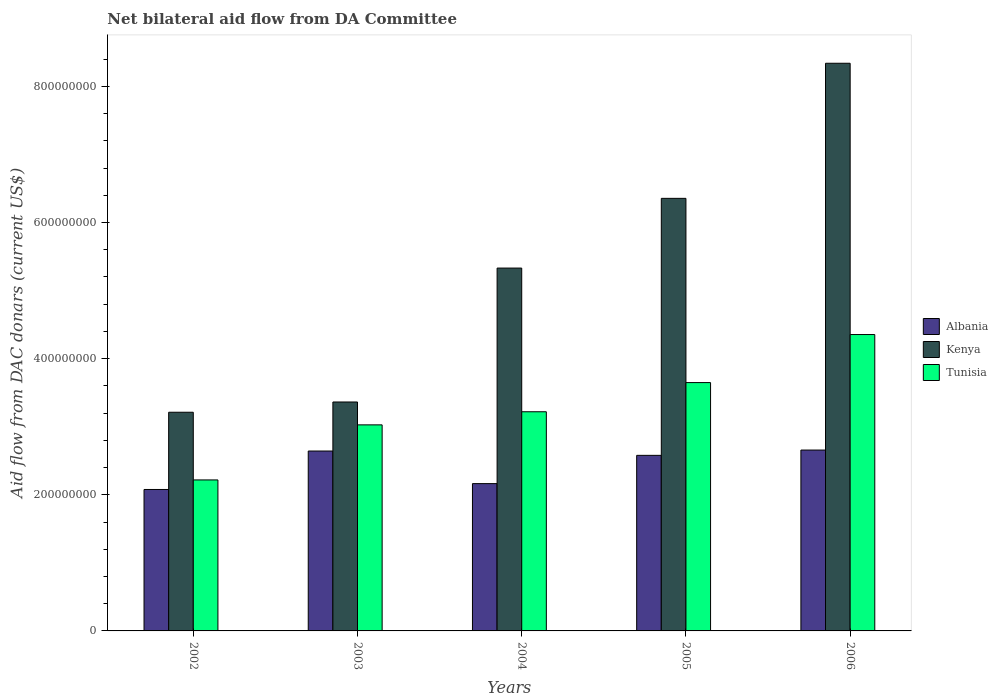How many groups of bars are there?
Give a very brief answer. 5. What is the aid flow in in Tunisia in 2005?
Provide a short and direct response. 3.65e+08. Across all years, what is the maximum aid flow in in Albania?
Keep it short and to the point. 2.66e+08. Across all years, what is the minimum aid flow in in Albania?
Make the answer very short. 2.08e+08. In which year was the aid flow in in Albania maximum?
Keep it short and to the point. 2006. What is the total aid flow in in Kenya in the graph?
Your answer should be very brief. 2.66e+09. What is the difference between the aid flow in in Albania in 2003 and that in 2004?
Offer a very short reply. 4.79e+07. What is the difference between the aid flow in in Tunisia in 2005 and the aid flow in in Kenya in 2006?
Your response must be concise. -4.69e+08. What is the average aid flow in in Albania per year?
Your answer should be very brief. 2.42e+08. In the year 2006, what is the difference between the aid flow in in Kenya and aid flow in in Tunisia?
Make the answer very short. 3.99e+08. In how many years, is the aid flow in in Kenya greater than 240000000 US$?
Your answer should be compact. 5. What is the ratio of the aid flow in in Albania in 2002 to that in 2006?
Your answer should be compact. 0.78. Is the difference between the aid flow in in Kenya in 2004 and 2006 greater than the difference between the aid flow in in Tunisia in 2004 and 2006?
Provide a short and direct response. No. What is the difference between the highest and the second highest aid flow in in Tunisia?
Keep it short and to the point. 7.06e+07. What is the difference between the highest and the lowest aid flow in in Kenya?
Make the answer very short. 5.13e+08. What does the 2nd bar from the left in 2006 represents?
Ensure brevity in your answer.  Kenya. What does the 3rd bar from the right in 2005 represents?
Your response must be concise. Albania. Is it the case that in every year, the sum of the aid flow in in Tunisia and aid flow in in Kenya is greater than the aid flow in in Albania?
Make the answer very short. Yes. How many bars are there?
Offer a terse response. 15. Are all the bars in the graph horizontal?
Give a very brief answer. No. How many years are there in the graph?
Keep it short and to the point. 5. What is the difference between two consecutive major ticks on the Y-axis?
Keep it short and to the point. 2.00e+08. Where does the legend appear in the graph?
Make the answer very short. Center right. How many legend labels are there?
Offer a very short reply. 3. How are the legend labels stacked?
Ensure brevity in your answer.  Vertical. What is the title of the graph?
Your response must be concise. Net bilateral aid flow from DA Committee. What is the label or title of the Y-axis?
Give a very brief answer. Aid flow from DAC donars (current US$). What is the Aid flow from DAC donars (current US$) in Albania in 2002?
Your response must be concise. 2.08e+08. What is the Aid flow from DAC donars (current US$) of Kenya in 2002?
Provide a succinct answer. 3.21e+08. What is the Aid flow from DAC donars (current US$) in Tunisia in 2002?
Your answer should be very brief. 2.22e+08. What is the Aid flow from DAC donars (current US$) in Albania in 2003?
Your response must be concise. 2.64e+08. What is the Aid flow from DAC donars (current US$) of Kenya in 2003?
Ensure brevity in your answer.  3.36e+08. What is the Aid flow from DAC donars (current US$) in Tunisia in 2003?
Your response must be concise. 3.03e+08. What is the Aid flow from DAC donars (current US$) of Albania in 2004?
Offer a terse response. 2.16e+08. What is the Aid flow from DAC donars (current US$) in Kenya in 2004?
Ensure brevity in your answer.  5.33e+08. What is the Aid flow from DAC donars (current US$) in Tunisia in 2004?
Provide a succinct answer. 3.22e+08. What is the Aid flow from DAC donars (current US$) in Albania in 2005?
Your answer should be compact. 2.58e+08. What is the Aid flow from DAC donars (current US$) in Kenya in 2005?
Make the answer very short. 6.35e+08. What is the Aid flow from DAC donars (current US$) of Tunisia in 2005?
Provide a succinct answer. 3.65e+08. What is the Aid flow from DAC donars (current US$) in Albania in 2006?
Give a very brief answer. 2.66e+08. What is the Aid flow from DAC donars (current US$) of Kenya in 2006?
Your answer should be compact. 8.34e+08. What is the Aid flow from DAC donars (current US$) of Tunisia in 2006?
Provide a succinct answer. 4.35e+08. Across all years, what is the maximum Aid flow from DAC donars (current US$) in Albania?
Offer a very short reply. 2.66e+08. Across all years, what is the maximum Aid flow from DAC donars (current US$) of Kenya?
Your response must be concise. 8.34e+08. Across all years, what is the maximum Aid flow from DAC donars (current US$) in Tunisia?
Offer a very short reply. 4.35e+08. Across all years, what is the minimum Aid flow from DAC donars (current US$) in Albania?
Your answer should be compact. 2.08e+08. Across all years, what is the minimum Aid flow from DAC donars (current US$) of Kenya?
Your response must be concise. 3.21e+08. Across all years, what is the minimum Aid flow from DAC donars (current US$) of Tunisia?
Give a very brief answer. 2.22e+08. What is the total Aid flow from DAC donars (current US$) of Albania in the graph?
Offer a terse response. 1.21e+09. What is the total Aid flow from DAC donars (current US$) of Kenya in the graph?
Offer a very short reply. 2.66e+09. What is the total Aid flow from DAC donars (current US$) in Tunisia in the graph?
Give a very brief answer. 1.65e+09. What is the difference between the Aid flow from DAC donars (current US$) of Albania in 2002 and that in 2003?
Offer a terse response. -5.65e+07. What is the difference between the Aid flow from DAC donars (current US$) in Kenya in 2002 and that in 2003?
Give a very brief answer. -1.51e+07. What is the difference between the Aid flow from DAC donars (current US$) in Tunisia in 2002 and that in 2003?
Keep it short and to the point. -8.09e+07. What is the difference between the Aid flow from DAC donars (current US$) in Albania in 2002 and that in 2004?
Make the answer very short. -8.60e+06. What is the difference between the Aid flow from DAC donars (current US$) in Kenya in 2002 and that in 2004?
Offer a terse response. -2.12e+08. What is the difference between the Aid flow from DAC donars (current US$) of Tunisia in 2002 and that in 2004?
Your answer should be compact. -1.00e+08. What is the difference between the Aid flow from DAC donars (current US$) of Albania in 2002 and that in 2005?
Keep it short and to the point. -5.01e+07. What is the difference between the Aid flow from DAC donars (current US$) in Kenya in 2002 and that in 2005?
Make the answer very short. -3.14e+08. What is the difference between the Aid flow from DAC donars (current US$) of Tunisia in 2002 and that in 2005?
Your answer should be very brief. -1.43e+08. What is the difference between the Aid flow from DAC donars (current US$) of Albania in 2002 and that in 2006?
Your response must be concise. -5.79e+07. What is the difference between the Aid flow from DAC donars (current US$) in Kenya in 2002 and that in 2006?
Your response must be concise. -5.13e+08. What is the difference between the Aid flow from DAC donars (current US$) in Tunisia in 2002 and that in 2006?
Give a very brief answer. -2.14e+08. What is the difference between the Aid flow from DAC donars (current US$) in Albania in 2003 and that in 2004?
Give a very brief answer. 4.79e+07. What is the difference between the Aid flow from DAC donars (current US$) of Kenya in 2003 and that in 2004?
Offer a very short reply. -1.97e+08. What is the difference between the Aid flow from DAC donars (current US$) in Tunisia in 2003 and that in 2004?
Your answer should be very brief. -1.92e+07. What is the difference between the Aid flow from DAC donars (current US$) of Albania in 2003 and that in 2005?
Ensure brevity in your answer.  6.36e+06. What is the difference between the Aid flow from DAC donars (current US$) in Kenya in 2003 and that in 2005?
Your answer should be compact. -2.99e+08. What is the difference between the Aid flow from DAC donars (current US$) in Tunisia in 2003 and that in 2005?
Your answer should be very brief. -6.21e+07. What is the difference between the Aid flow from DAC donars (current US$) in Albania in 2003 and that in 2006?
Your response must be concise. -1.43e+06. What is the difference between the Aid flow from DAC donars (current US$) in Kenya in 2003 and that in 2006?
Offer a very short reply. -4.98e+08. What is the difference between the Aid flow from DAC donars (current US$) of Tunisia in 2003 and that in 2006?
Ensure brevity in your answer.  -1.33e+08. What is the difference between the Aid flow from DAC donars (current US$) in Albania in 2004 and that in 2005?
Provide a short and direct response. -4.15e+07. What is the difference between the Aid flow from DAC donars (current US$) in Kenya in 2004 and that in 2005?
Your answer should be very brief. -1.02e+08. What is the difference between the Aid flow from DAC donars (current US$) in Tunisia in 2004 and that in 2005?
Ensure brevity in your answer.  -4.29e+07. What is the difference between the Aid flow from DAC donars (current US$) of Albania in 2004 and that in 2006?
Offer a very short reply. -4.93e+07. What is the difference between the Aid flow from DAC donars (current US$) in Kenya in 2004 and that in 2006?
Offer a terse response. -3.01e+08. What is the difference between the Aid flow from DAC donars (current US$) in Tunisia in 2004 and that in 2006?
Provide a succinct answer. -1.13e+08. What is the difference between the Aid flow from DAC donars (current US$) in Albania in 2005 and that in 2006?
Keep it short and to the point. -7.79e+06. What is the difference between the Aid flow from DAC donars (current US$) of Kenya in 2005 and that in 2006?
Offer a terse response. -1.98e+08. What is the difference between the Aid flow from DAC donars (current US$) of Tunisia in 2005 and that in 2006?
Give a very brief answer. -7.06e+07. What is the difference between the Aid flow from DAC donars (current US$) in Albania in 2002 and the Aid flow from DAC donars (current US$) in Kenya in 2003?
Make the answer very short. -1.29e+08. What is the difference between the Aid flow from DAC donars (current US$) of Albania in 2002 and the Aid flow from DAC donars (current US$) of Tunisia in 2003?
Provide a succinct answer. -9.49e+07. What is the difference between the Aid flow from DAC donars (current US$) in Kenya in 2002 and the Aid flow from DAC donars (current US$) in Tunisia in 2003?
Your answer should be very brief. 1.85e+07. What is the difference between the Aid flow from DAC donars (current US$) in Albania in 2002 and the Aid flow from DAC donars (current US$) in Kenya in 2004?
Make the answer very short. -3.25e+08. What is the difference between the Aid flow from DAC donars (current US$) of Albania in 2002 and the Aid flow from DAC donars (current US$) of Tunisia in 2004?
Provide a succinct answer. -1.14e+08. What is the difference between the Aid flow from DAC donars (current US$) of Kenya in 2002 and the Aid flow from DAC donars (current US$) of Tunisia in 2004?
Provide a short and direct response. -7.10e+05. What is the difference between the Aid flow from DAC donars (current US$) in Albania in 2002 and the Aid flow from DAC donars (current US$) in Kenya in 2005?
Give a very brief answer. -4.28e+08. What is the difference between the Aid flow from DAC donars (current US$) of Albania in 2002 and the Aid flow from DAC donars (current US$) of Tunisia in 2005?
Provide a succinct answer. -1.57e+08. What is the difference between the Aid flow from DAC donars (current US$) of Kenya in 2002 and the Aid flow from DAC donars (current US$) of Tunisia in 2005?
Offer a very short reply. -4.36e+07. What is the difference between the Aid flow from DAC donars (current US$) of Albania in 2002 and the Aid flow from DAC donars (current US$) of Kenya in 2006?
Your response must be concise. -6.26e+08. What is the difference between the Aid flow from DAC donars (current US$) of Albania in 2002 and the Aid flow from DAC donars (current US$) of Tunisia in 2006?
Ensure brevity in your answer.  -2.28e+08. What is the difference between the Aid flow from DAC donars (current US$) in Kenya in 2002 and the Aid flow from DAC donars (current US$) in Tunisia in 2006?
Provide a short and direct response. -1.14e+08. What is the difference between the Aid flow from DAC donars (current US$) of Albania in 2003 and the Aid flow from DAC donars (current US$) of Kenya in 2004?
Make the answer very short. -2.69e+08. What is the difference between the Aid flow from DAC donars (current US$) of Albania in 2003 and the Aid flow from DAC donars (current US$) of Tunisia in 2004?
Ensure brevity in your answer.  -5.77e+07. What is the difference between the Aid flow from DAC donars (current US$) of Kenya in 2003 and the Aid flow from DAC donars (current US$) of Tunisia in 2004?
Offer a very short reply. 1.44e+07. What is the difference between the Aid flow from DAC donars (current US$) of Albania in 2003 and the Aid flow from DAC donars (current US$) of Kenya in 2005?
Give a very brief answer. -3.71e+08. What is the difference between the Aid flow from DAC donars (current US$) of Albania in 2003 and the Aid flow from DAC donars (current US$) of Tunisia in 2005?
Make the answer very short. -1.01e+08. What is the difference between the Aid flow from DAC donars (current US$) in Kenya in 2003 and the Aid flow from DAC donars (current US$) in Tunisia in 2005?
Make the answer very short. -2.85e+07. What is the difference between the Aid flow from DAC donars (current US$) in Albania in 2003 and the Aid flow from DAC donars (current US$) in Kenya in 2006?
Keep it short and to the point. -5.70e+08. What is the difference between the Aid flow from DAC donars (current US$) of Albania in 2003 and the Aid flow from DAC donars (current US$) of Tunisia in 2006?
Make the answer very short. -1.71e+08. What is the difference between the Aid flow from DAC donars (current US$) in Kenya in 2003 and the Aid flow from DAC donars (current US$) in Tunisia in 2006?
Provide a succinct answer. -9.91e+07. What is the difference between the Aid flow from DAC donars (current US$) of Albania in 2004 and the Aid flow from DAC donars (current US$) of Kenya in 2005?
Your response must be concise. -4.19e+08. What is the difference between the Aid flow from DAC donars (current US$) of Albania in 2004 and the Aid flow from DAC donars (current US$) of Tunisia in 2005?
Provide a succinct answer. -1.48e+08. What is the difference between the Aid flow from DAC donars (current US$) in Kenya in 2004 and the Aid flow from DAC donars (current US$) in Tunisia in 2005?
Your answer should be very brief. 1.68e+08. What is the difference between the Aid flow from DAC donars (current US$) of Albania in 2004 and the Aid flow from DAC donars (current US$) of Kenya in 2006?
Offer a terse response. -6.18e+08. What is the difference between the Aid flow from DAC donars (current US$) in Albania in 2004 and the Aid flow from DAC donars (current US$) in Tunisia in 2006?
Offer a terse response. -2.19e+08. What is the difference between the Aid flow from DAC donars (current US$) of Kenya in 2004 and the Aid flow from DAC donars (current US$) of Tunisia in 2006?
Offer a terse response. 9.76e+07. What is the difference between the Aid flow from DAC donars (current US$) in Albania in 2005 and the Aid flow from DAC donars (current US$) in Kenya in 2006?
Provide a succinct answer. -5.76e+08. What is the difference between the Aid flow from DAC donars (current US$) of Albania in 2005 and the Aid flow from DAC donars (current US$) of Tunisia in 2006?
Give a very brief answer. -1.77e+08. What is the difference between the Aid flow from DAC donars (current US$) in Kenya in 2005 and the Aid flow from DAC donars (current US$) in Tunisia in 2006?
Ensure brevity in your answer.  2.00e+08. What is the average Aid flow from DAC donars (current US$) in Albania per year?
Make the answer very short. 2.42e+08. What is the average Aid flow from DAC donars (current US$) of Kenya per year?
Keep it short and to the point. 5.32e+08. What is the average Aid flow from DAC donars (current US$) of Tunisia per year?
Keep it short and to the point. 3.29e+08. In the year 2002, what is the difference between the Aid flow from DAC donars (current US$) in Albania and Aid flow from DAC donars (current US$) in Kenya?
Your answer should be very brief. -1.13e+08. In the year 2002, what is the difference between the Aid flow from DAC donars (current US$) in Albania and Aid flow from DAC donars (current US$) in Tunisia?
Keep it short and to the point. -1.40e+07. In the year 2002, what is the difference between the Aid flow from DAC donars (current US$) of Kenya and Aid flow from DAC donars (current US$) of Tunisia?
Your answer should be compact. 9.94e+07. In the year 2003, what is the difference between the Aid flow from DAC donars (current US$) of Albania and Aid flow from DAC donars (current US$) of Kenya?
Ensure brevity in your answer.  -7.20e+07. In the year 2003, what is the difference between the Aid flow from DAC donars (current US$) in Albania and Aid flow from DAC donars (current US$) in Tunisia?
Keep it short and to the point. -3.84e+07. In the year 2003, what is the difference between the Aid flow from DAC donars (current US$) in Kenya and Aid flow from DAC donars (current US$) in Tunisia?
Give a very brief answer. 3.36e+07. In the year 2004, what is the difference between the Aid flow from DAC donars (current US$) in Albania and Aid flow from DAC donars (current US$) in Kenya?
Offer a terse response. -3.17e+08. In the year 2004, what is the difference between the Aid flow from DAC donars (current US$) of Albania and Aid flow from DAC donars (current US$) of Tunisia?
Provide a short and direct response. -1.06e+08. In the year 2004, what is the difference between the Aid flow from DAC donars (current US$) of Kenya and Aid flow from DAC donars (current US$) of Tunisia?
Offer a terse response. 2.11e+08. In the year 2005, what is the difference between the Aid flow from DAC donars (current US$) of Albania and Aid flow from DAC donars (current US$) of Kenya?
Provide a succinct answer. -3.78e+08. In the year 2005, what is the difference between the Aid flow from DAC donars (current US$) of Albania and Aid flow from DAC donars (current US$) of Tunisia?
Offer a terse response. -1.07e+08. In the year 2005, what is the difference between the Aid flow from DAC donars (current US$) of Kenya and Aid flow from DAC donars (current US$) of Tunisia?
Ensure brevity in your answer.  2.71e+08. In the year 2006, what is the difference between the Aid flow from DAC donars (current US$) in Albania and Aid flow from DAC donars (current US$) in Kenya?
Offer a terse response. -5.68e+08. In the year 2006, what is the difference between the Aid flow from DAC donars (current US$) of Albania and Aid flow from DAC donars (current US$) of Tunisia?
Your answer should be compact. -1.70e+08. In the year 2006, what is the difference between the Aid flow from DAC donars (current US$) of Kenya and Aid flow from DAC donars (current US$) of Tunisia?
Your answer should be very brief. 3.99e+08. What is the ratio of the Aid flow from DAC donars (current US$) of Albania in 2002 to that in 2003?
Your answer should be compact. 0.79. What is the ratio of the Aid flow from DAC donars (current US$) in Kenya in 2002 to that in 2003?
Offer a very short reply. 0.96. What is the ratio of the Aid flow from DAC donars (current US$) in Tunisia in 2002 to that in 2003?
Keep it short and to the point. 0.73. What is the ratio of the Aid flow from DAC donars (current US$) in Albania in 2002 to that in 2004?
Ensure brevity in your answer.  0.96. What is the ratio of the Aid flow from DAC donars (current US$) in Kenya in 2002 to that in 2004?
Offer a terse response. 0.6. What is the ratio of the Aid flow from DAC donars (current US$) of Tunisia in 2002 to that in 2004?
Offer a very short reply. 0.69. What is the ratio of the Aid flow from DAC donars (current US$) in Albania in 2002 to that in 2005?
Provide a succinct answer. 0.81. What is the ratio of the Aid flow from DAC donars (current US$) of Kenya in 2002 to that in 2005?
Provide a succinct answer. 0.51. What is the ratio of the Aid flow from DAC donars (current US$) of Tunisia in 2002 to that in 2005?
Ensure brevity in your answer.  0.61. What is the ratio of the Aid flow from DAC donars (current US$) in Albania in 2002 to that in 2006?
Your answer should be compact. 0.78. What is the ratio of the Aid flow from DAC donars (current US$) of Kenya in 2002 to that in 2006?
Provide a succinct answer. 0.39. What is the ratio of the Aid flow from DAC donars (current US$) of Tunisia in 2002 to that in 2006?
Your answer should be compact. 0.51. What is the ratio of the Aid flow from DAC donars (current US$) of Albania in 2003 to that in 2004?
Make the answer very short. 1.22. What is the ratio of the Aid flow from DAC donars (current US$) of Kenya in 2003 to that in 2004?
Your answer should be compact. 0.63. What is the ratio of the Aid flow from DAC donars (current US$) in Tunisia in 2003 to that in 2004?
Offer a very short reply. 0.94. What is the ratio of the Aid flow from DAC donars (current US$) of Albania in 2003 to that in 2005?
Ensure brevity in your answer.  1.02. What is the ratio of the Aid flow from DAC donars (current US$) of Kenya in 2003 to that in 2005?
Your response must be concise. 0.53. What is the ratio of the Aid flow from DAC donars (current US$) in Tunisia in 2003 to that in 2005?
Offer a very short reply. 0.83. What is the ratio of the Aid flow from DAC donars (current US$) of Kenya in 2003 to that in 2006?
Provide a short and direct response. 0.4. What is the ratio of the Aid flow from DAC donars (current US$) in Tunisia in 2003 to that in 2006?
Offer a very short reply. 0.7. What is the ratio of the Aid flow from DAC donars (current US$) of Albania in 2004 to that in 2005?
Give a very brief answer. 0.84. What is the ratio of the Aid flow from DAC donars (current US$) of Kenya in 2004 to that in 2005?
Your response must be concise. 0.84. What is the ratio of the Aid flow from DAC donars (current US$) of Tunisia in 2004 to that in 2005?
Your response must be concise. 0.88. What is the ratio of the Aid flow from DAC donars (current US$) in Albania in 2004 to that in 2006?
Give a very brief answer. 0.81. What is the ratio of the Aid flow from DAC donars (current US$) in Kenya in 2004 to that in 2006?
Offer a terse response. 0.64. What is the ratio of the Aid flow from DAC donars (current US$) of Tunisia in 2004 to that in 2006?
Offer a terse response. 0.74. What is the ratio of the Aid flow from DAC donars (current US$) in Albania in 2005 to that in 2006?
Your response must be concise. 0.97. What is the ratio of the Aid flow from DAC donars (current US$) in Kenya in 2005 to that in 2006?
Give a very brief answer. 0.76. What is the ratio of the Aid flow from DAC donars (current US$) in Tunisia in 2005 to that in 2006?
Keep it short and to the point. 0.84. What is the difference between the highest and the second highest Aid flow from DAC donars (current US$) of Albania?
Your answer should be very brief. 1.43e+06. What is the difference between the highest and the second highest Aid flow from DAC donars (current US$) of Kenya?
Offer a terse response. 1.98e+08. What is the difference between the highest and the second highest Aid flow from DAC donars (current US$) of Tunisia?
Make the answer very short. 7.06e+07. What is the difference between the highest and the lowest Aid flow from DAC donars (current US$) of Albania?
Your response must be concise. 5.79e+07. What is the difference between the highest and the lowest Aid flow from DAC donars (current US$) in Kenya?
Make the answer very short. 5.13e+08. What is the difference between the highest and the lowest Aid flow from DAC donars (current US$) in Tunisia?
Give a very brief answer. 2.14e+08. 